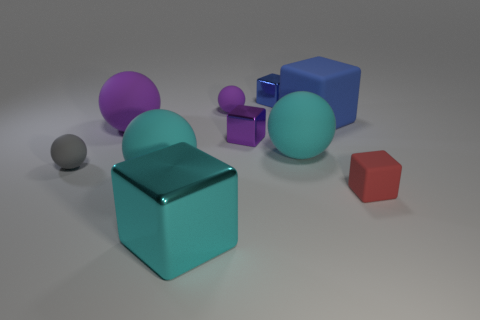Subtract all cyan cubes. How many cubes are left? 4 Subtract all tiny matte cubes. How many cubes are left? 4 Subtract 3 balls. How many balls are left? 2 Subtract all yellow blocks. Subtract all gray cylinders. How many blocks are left? 5 Add 2 big cyan cubes. How many big cyan cubes are left? 3 Add 4 red objects. How many red objects exist? 5 Subtract 0 purple cylinders. How many objects are left? 10 Subtract all small gray rubber spheres. Subtract all big cyan balls. How many objects are left? 7 